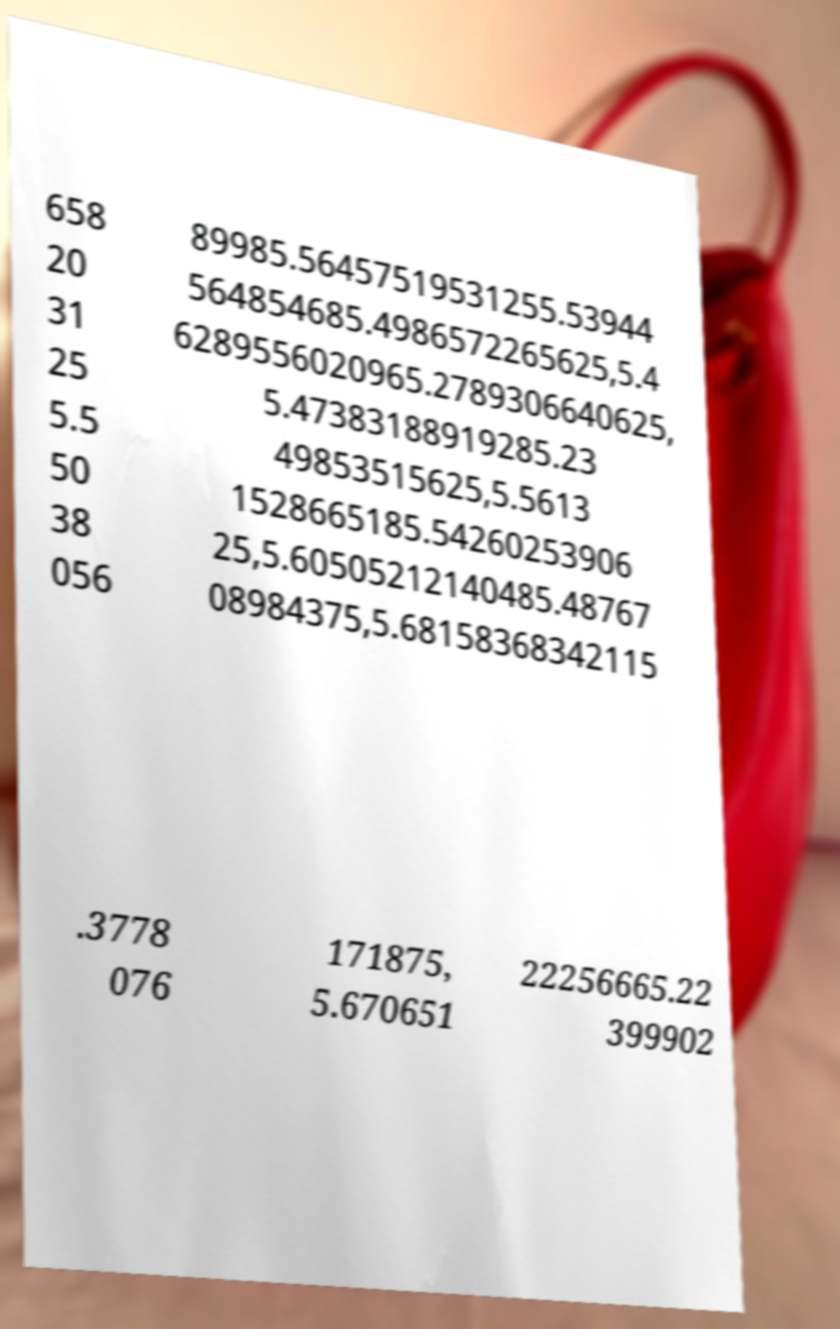Can you read and provide the text displayed in the image?This photo seems to have some interesting text. Can you extract and type it out for me? 658 20 31 25 5.5 50 38 056 89985.56457519531255.53944 564854685.4986572265625,5.4 6289556020965.2789306640625, 5.47383188919285.23 49853515625,5.5613 1528665185.54260253906 25,5.60505212140485.48767 08984375,5.68158368342115 .3778 076 171875, 5.670651 22256665.22 399902 